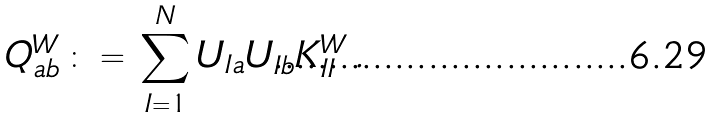<formula> <loc_0><loc_0><loc_500><loc_500>Q _ { a b } ^ { W } \, \colon = \, \sum _ { I = 1 } ^ { N } U _ { I a } U _ { I b } K _ { I I } ^ { W } \, .</formula> 